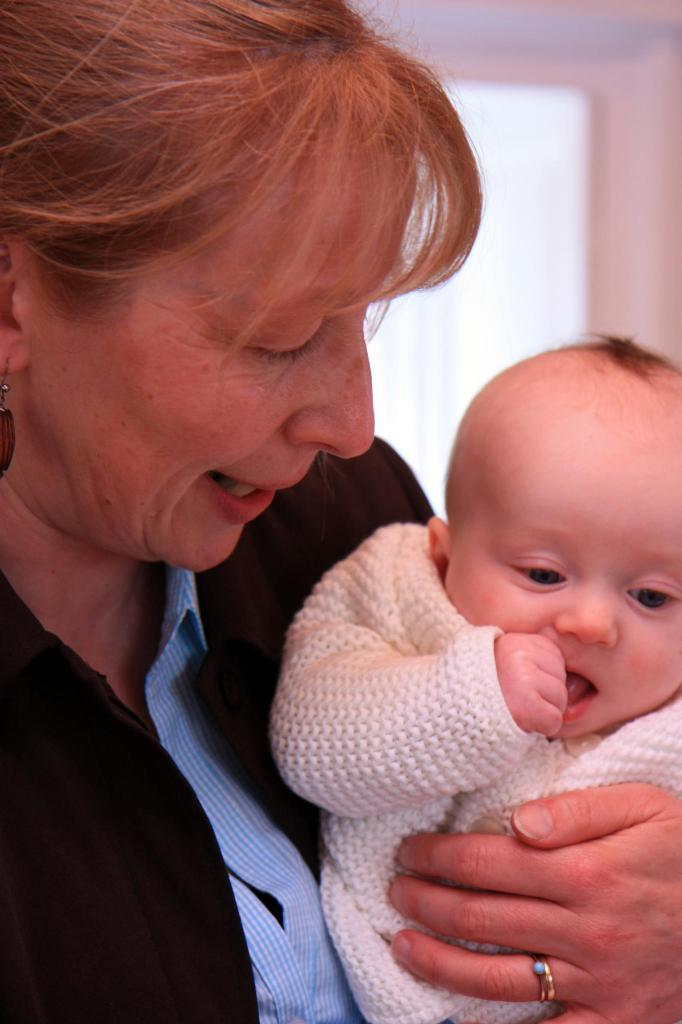What is the lady in the image holding? The lady is holding a baby in the image. What can be seen in the top right corner of the image? The wall, window, and roof are visible in the top right corner of the image. What type of texture can be seen on the shop's sign in the image? There is no shop or sign present in the image; it features a lady holding a baby and a wall, window, and roof in the top right corner. 